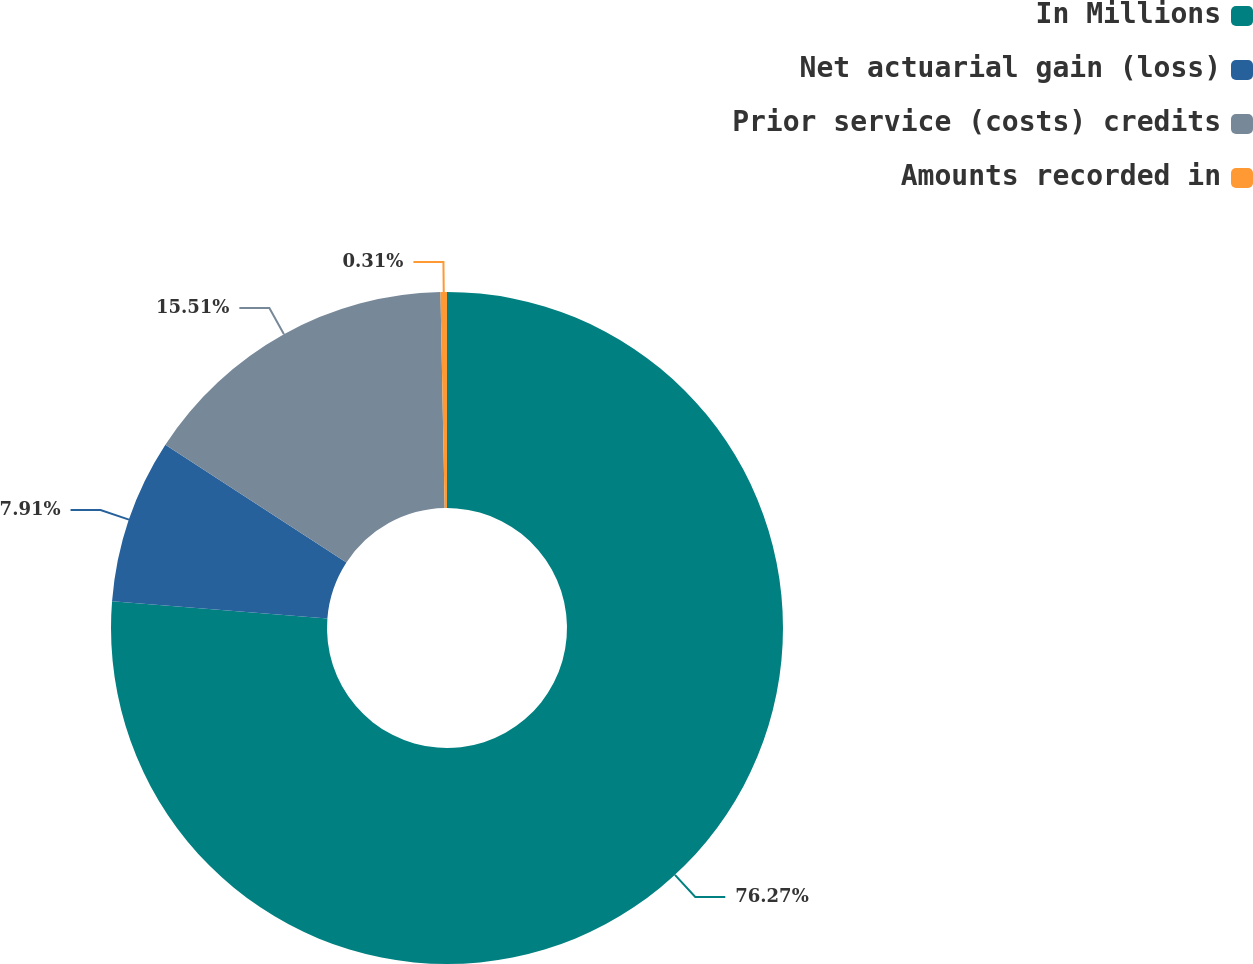Convert chart. <chart><loc_0><loc_0><loc_500><loc_500><pie_chart><fcel>In Millions<fcel>Net actuarial gain (loss)<fcel>Prior service (costs) credits<fcel>Amounts recorded in<nl><fcel>76.27%<fcel>7.91%<fcel>15.51%<fcel>0.31%<nl></chart> 